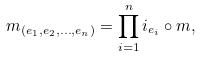Convert formula to latex. <formula><loc_0><loc_0><loc_500><loc_500>m _ { ( e _ { 1 } , e _ { 2 } , \dots , e _ { n } ) } = \prod _ { i = 1 } ^ { n } i _ { e _ { i } } \circ m ,</formula> 